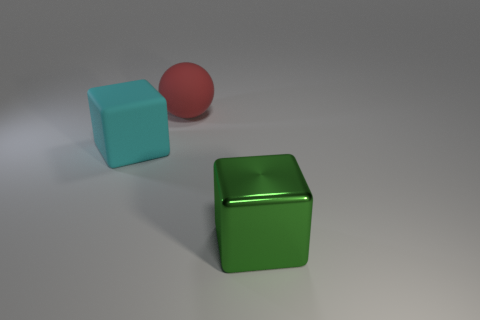Subtract 0 yellow blocks. How many objects are left? 3 Subtract all balls. How many objects are left? 2 Subtract 2 cubes. How many cubes are left? 0 Subtract all green balls. Subtract all brown cylinders. How many balls are left? 1 Subtract all brown blocks. How many blue spheres are left? 0 Subtract all big red rubber spheres. Subtract all small balls. How many objects are left? 2 Add 2 big objects. How many big objects are left? 5 Add 2 spheres. How many spheres exist? 3 Add 2 tiny green shiny spheres. How many objects exist? 5 Subtract all cyan blocks. How many blocks are left? 1 